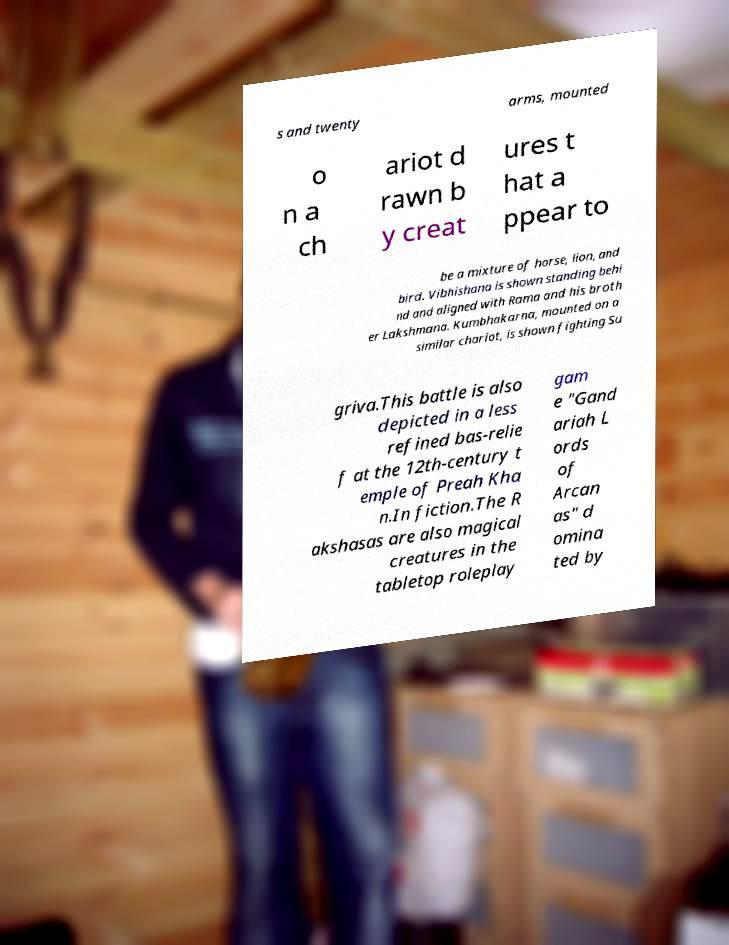For documentation purposes, I need the text within this image transcribed. Could you provide that? s and twenty arms, mounted o n a ch ariot d rawn b y creat ures t hat a ppear to be a mixture of horse, lion, and bird. Vibhishana is shown standing behi nd and aligned with Rama and his broth er Lakshmana. Kumbhakarna, mounted on a similar chariot, is shown fighting Su griva.This battle is also depicted in a less refined bas-relie f at the 12th-century t emple of Preah Kha n.In fiction.The R akshasas are also magical creatures in the tabletop roleplay gam e "Gand ariah L ords of Arcan as" d omina ted by 